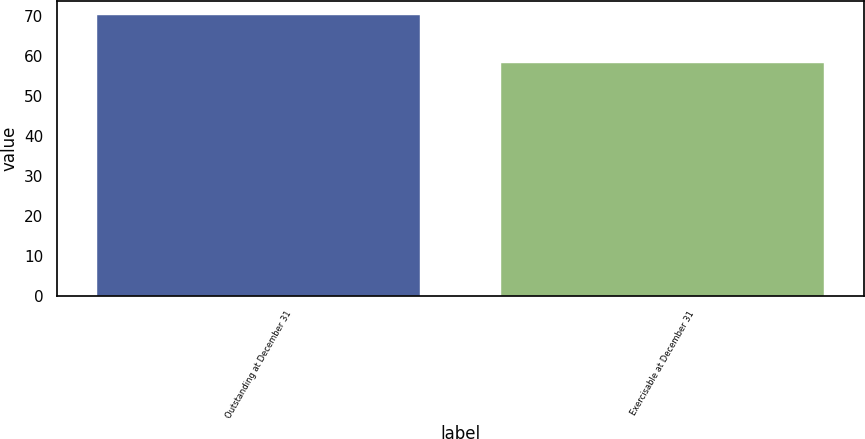Convert chart to OTSL. <chart><loc_0><loc_0><loc_500><loc_500><bar_chart><fcel>Outstanding at December 31<fcel>Exercisable at December 31<nl><fcel>70.27<fcel>58.34<nl></chart> 